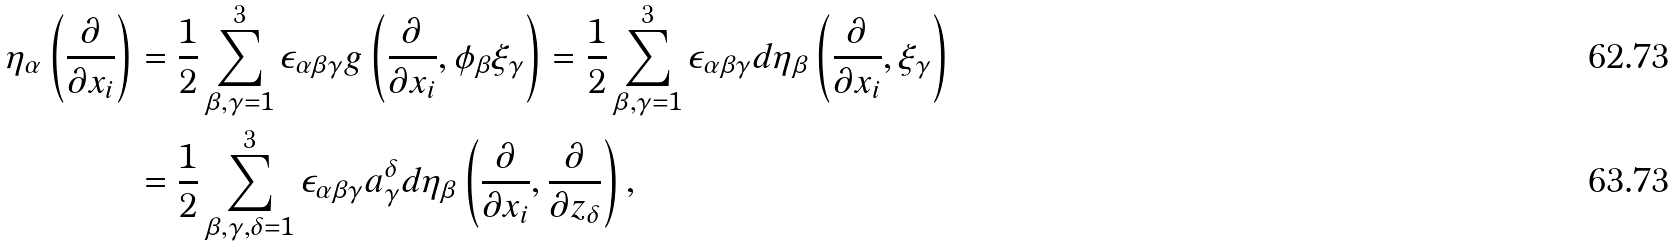<formula> <loc_0><loc_0><loc_500><loc_500>\eta _ { \alpha } \left ( \frac { \partial } { \partial x _ { i } } \right ) & = \frac { 1 } { 2 } \sum _ { \beta , \gamma = 1 } ^ { 3 } \epsilon _ { \alpha \beta \gamma } g \left ( \frac { \partial } { \partial x _ { i } } , \phi _ { \beta } \xi _ { \gamma } \right ) = \frac { 1 } { 2 } \sum _ { \beta , \gamma = 1 } ^ { 3 } \epsilon _ { \alpha \beta \gamma } d \eta _ { \beta } \left ( \frac { \partial } { \partial x _ { i } } , \xi _ { \gamma } \right ) \\ & = \frac { 1 } { 2 } \sum _ { \beta , \gamma , \delta = 1 } ^ { 3 } \epsilon _ { \alpha \beta \gamma } a ^ { \delta } _ { \gamma } d \eta _ { \beta } \left ( \frac { \partial } { \partial x _ { i } } , \frac { \partial } { \partial z _ { \delta } } \right ) ,</formula> 